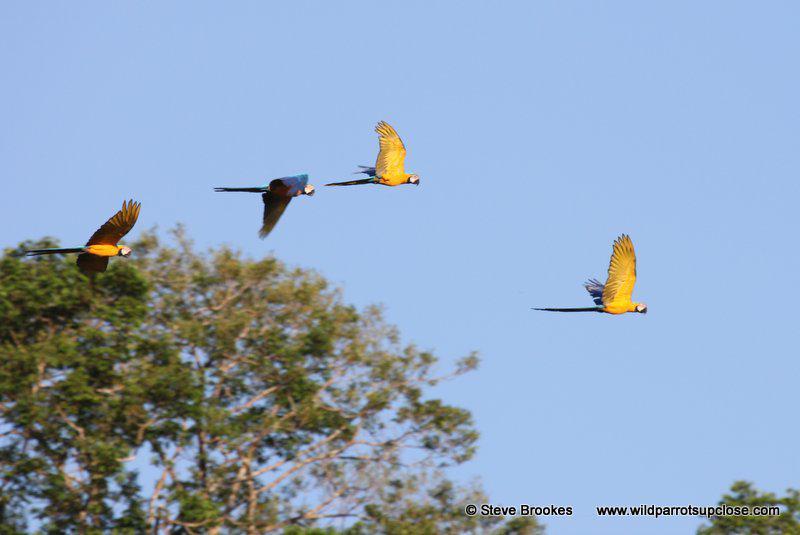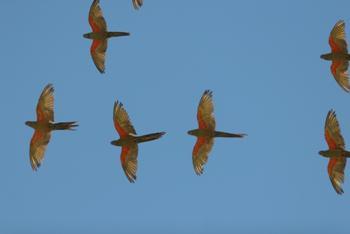The first image is the image on the left, the second image is the image on the right. For the images shown, is this caption "the birds are in flight showing their bellies" true? Answer yes or no. Yes. The first image is the image on the left, the second image is the image on the right. For the images displayed, is the sentence "There is at least one parrot perched on something rather than in flight" factually correct? Answer yes or no. No. 